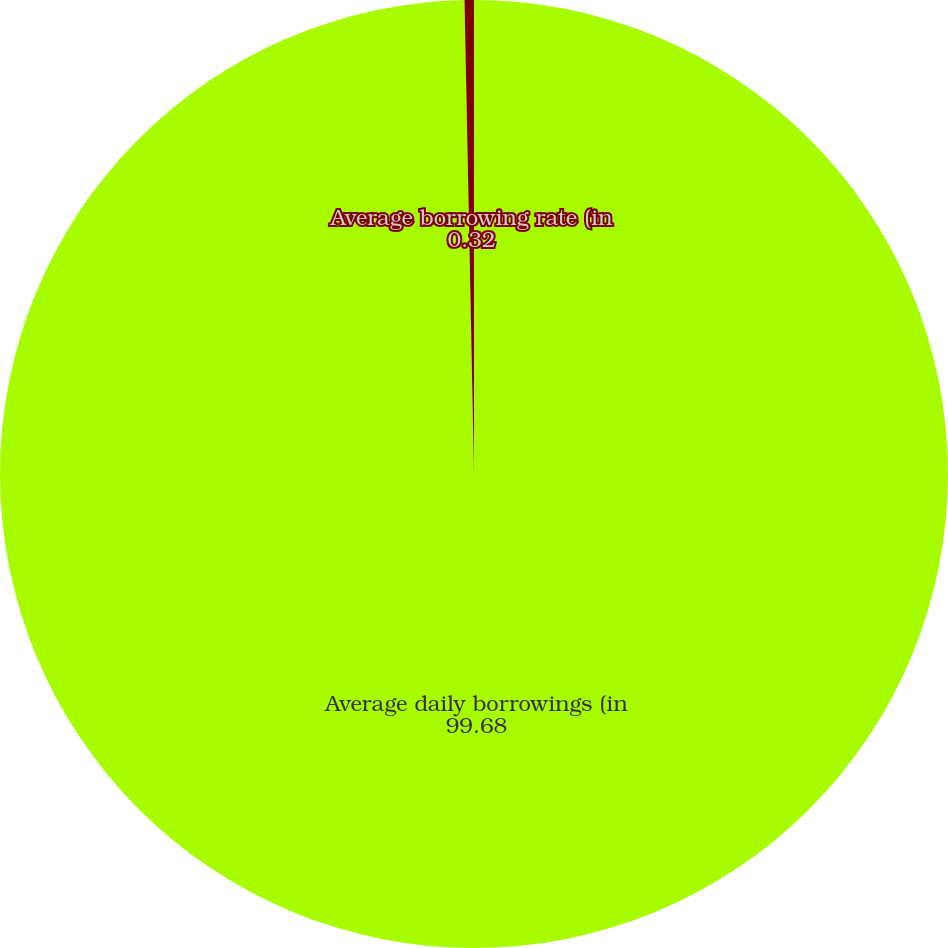Convert chart to OTSL. <chart><loc_0><loc_0><loc_500><loc_500><pie_chart><fcel>Average daily borrowings (in<fcel>Average borrowing rate (in<nl><fcel>99.68%<fcel>0.32%<nl></chart> 